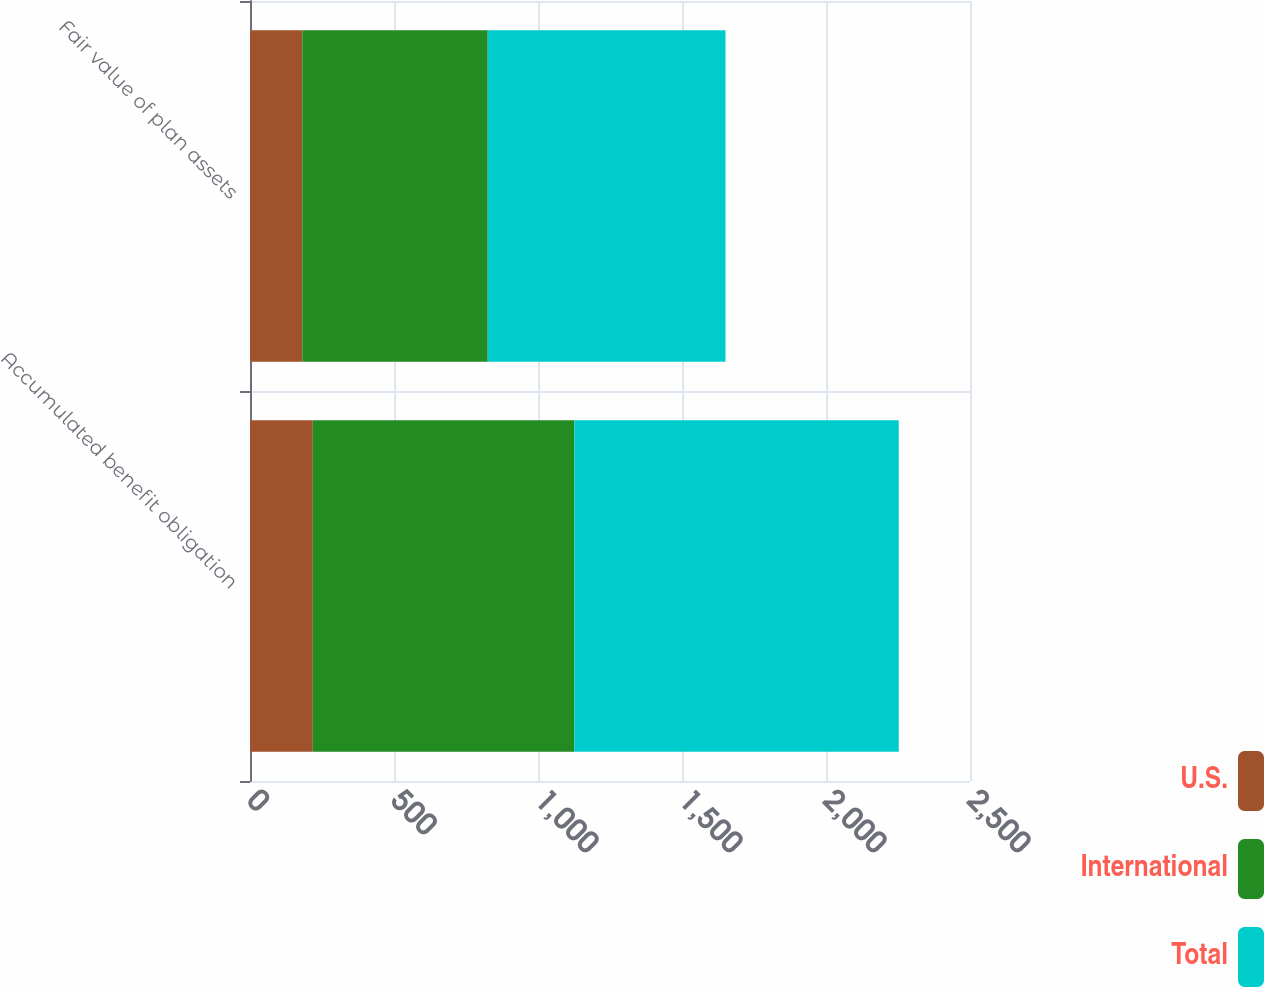Convert chart. <chart><loc_0><loc_0><loc_500><loc_500><stacked_bar_chart><ecel><fcel>Accumulated benefit obligation<fcel>Fair value of plan assets<nl><fcel>U.S.<fcel>218<fcel>181.7<nl><fcel>International<fcel>908.3<fcel>643.8<nl><fcel>Total<fcel>1126.3<fcel>825.5<nl></chart> 